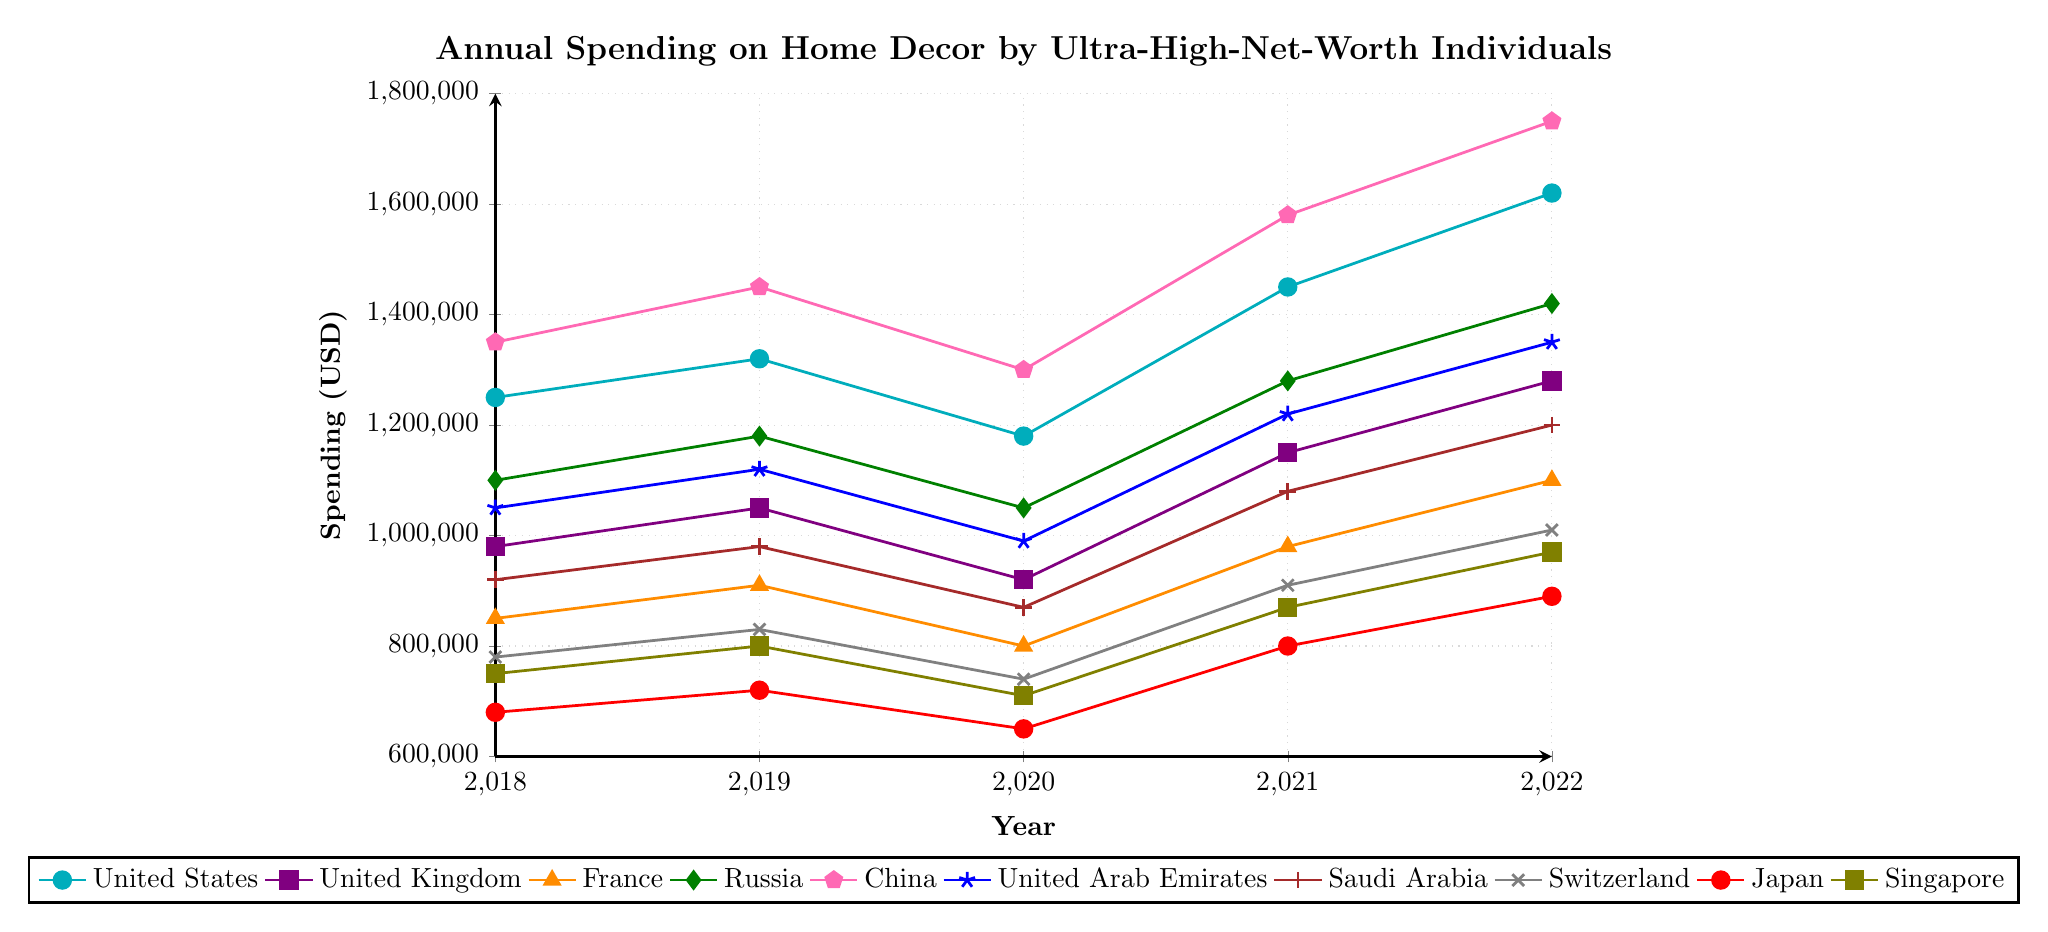Which country had the highest spending in 2022? Look at the data points for 2022 across all countries. China has the highest value at $1,750,000.
Answer: China Which country had the lowest spending in 2020? Look at the data points for 2020 across all countries. Japan has the lowest value at $650,000.
Answer: Japan What was the average spending on home decor in 2019 for United States, United Kingdom, and France? Add the values for the United States (1,320,000), United Kingdom (1,050,000), and France (910,000) for 2019: 1,320,000 + 1,050,000 + 910,000 = 3,280,000. Divide by 3 to get the average: 3,280,000 / 3 = 1,093,333.33.
Answer: 1,093,333.33 Compare the spending between Russia and the United Arab Emirates in 2021; which had higher spending? Look at the data points for 2021 for Russia and UAE. Russia has a value of 1,280,000, while UAE has a value of 1,220,000. Thus, Russia had higher spending.
Answer: Russia How much did spending increase in Japan from 2018 to 2022? Look at the values for Japan in 2018 (680,000) and 2022 (890,000). Subtract the 2018 value from the 2022 value: 890,000 - 680,000 = 210,000.
Answer: 210,000 Which country had the sharpest increase in spending from 2021 to 2022? Calculate the increase for each country from 2021 to 2022. The increases are as follows: USA: 1620000-1450000=170000, UK: 1280000-1150000=130000, France: 1100000-980000=120000, Russia: 1420000-1280000=140000, China: 1750000-1580000=170000, UAE: 1350000-1220000=130000, Saudi Arabia: 1200000-1080000=120000, Switzerland: 1010000-910000=100000, Japan: 890000-800000=90000, Singapore: 970000-870000=100000. The sharpest increases are USA and China with 170,000.
Answer: United States and China What is the median spending for the United Kingdom across all years? Arrange spending values for the UK: 980000, 1050000, 920000, 1150000, 1280000. The median is the middle value when they are ordered: 980000, 920000, 1050000, 1150000, 1280000. Median value is 1050000.
Answer: 1,050,000 For which country did spending decrease from 2019 to 2020? Look at the spending values from 2019 to 2020 for each country. The following countries have a decrease: USA: 1320000->1180000, UK: 1050000->920000, France: 910000->800000, Russia: 1180000->1050000, UAE: 1120000->990000, Saudi Arabia: 980000->870000, Switzerland: 830000->740000, Japan: 720000->650000, Singapore: 800000->710000.
Answer: USA, UK, France, Russia, UAE, Saudi Arabia, Switzerland, Japan, Singapore What color is the line representing China? Look at the plot legend and find the color associated with China. The line for China is in pink.
Answer: pink 